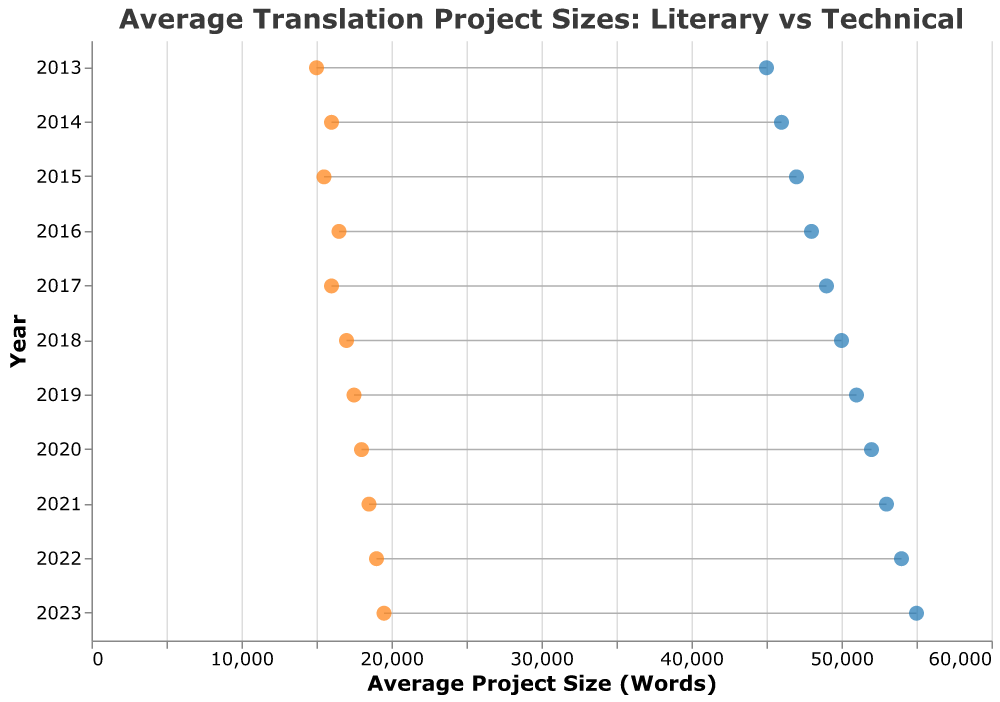What is the title of the plot? The title is clearly written at the top of the plot, which reads "Average Translation Project Sizes: Literary vs Technical".
Answer: Average Translation Project Sizes: Literary vs Technical What does the y-axis represent in the plot? By examining the labels on the y-axis, it's evident that the y-axis represents the years from 2013 to 2023.
Answer: Year What are the colors used for the literary and technical translation data points? The circles representing literary translation projects are in blue, while those representing technical translation projects are in orange.
Answer: Blue and Orange In which year was the average literary translation project size the smallest? By looking at the leftmost blue circle on the x-axis, it's clear that the smallest average literary translation project size is in the year 2013.
Answer: 2013 How much did the average technical translation project size increase from 2013 to 2023? The average technical translation project size in 2013 is 15000 words, while in 2023 it is 19500 words. The increase is therefore 19500 - 15000 = 4500 words.
Answer: 4500 words What is the difference between the average sizes of literary and technical translations in 2022? From the plot, the average size of literary translation in 2022 is 54000 words and for technical translation, it is 19000 words. The difference is 54000 - 19000 = 35000 words.
Answer: 35000 words What is the general trend of average project sizes for both literary and technical translations over the decade? Both the blue and orange circles show an upward trend from 2013 to 2023, indicating that the average project sizes for both literary and technical translations have increased over the decade.
Answer: Upward trend Which year has the smallest difference between literary and technical translation project sizes? By visually inspecting the plot, the difference is smallest in 2015 where literary projects are 47000 words and technical projects are 15500 words, giving a difference of 31500 words.
Answer: 2015 How many data points are there in total in the plot? There is one data point for each year from 2013 to 2023 for both literary and technical translations. Therefore, there are 11 years x 2 data points (literary and technical) = 22 data points.
Answer: 22 Which translation type has larger average project sizes consistently over the years? Throughout the plot from 2013 to 2023, the blue circles (literary translations) are always positioned to the right of the orange circles (technical translations), indicating that literary translations consistently have larger average project sizes.
Answer: Literary translations 